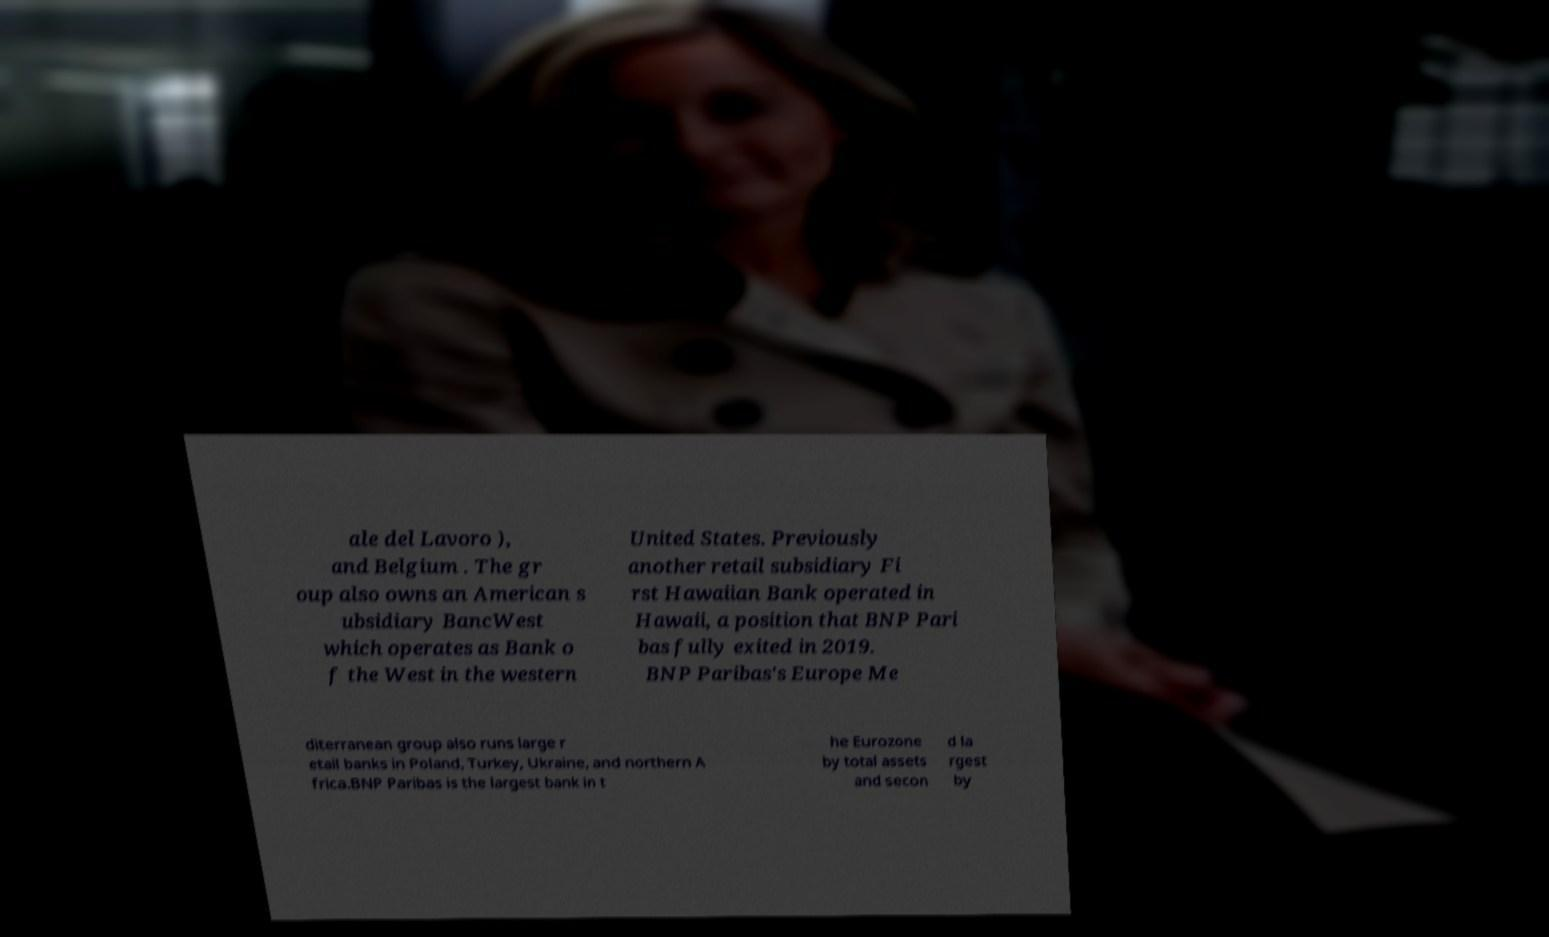Can you read and provide the text displayed in the image?This photo seems to have some interesting text. Can you extract and type it out for me? ale del Lavoro ), and Belgium . The gr oup also owns an American s ubsidiary BancWest which operates as Bank o f the West in the western United States. Previously another retail subsidiary Fi rst Hawaiian Bank operated in Hawaii, a position that BNP Pari bas fully exited in 2019. BNP Paribas's Europe Me diterranean group also runs large r etail banks in Poland, Turkey, Ukraine, and northern A frica.BNP Paribas is the largest bank in t he Eurozone by total assets and secon d la rgest by 